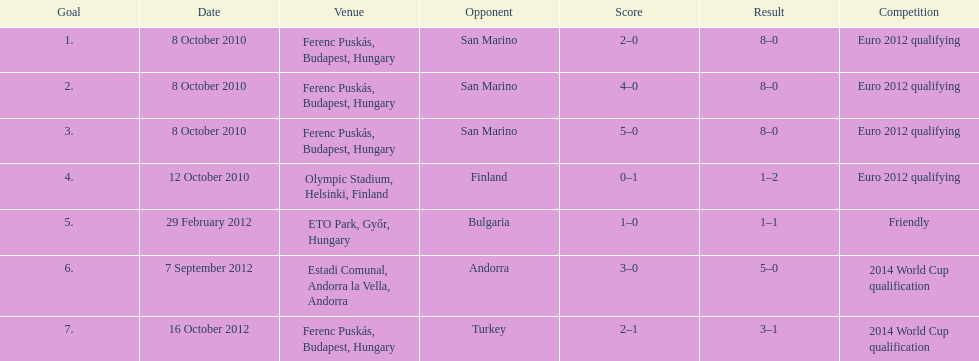Can you give me this table as a dict? {'header': ['Goal', 'Date', 'Venue', 'Opponent', 'Score', 'Result', 'Competition'], 'rows': [['1.', '8 October 2010', 'Ferenc Puskás, Budapest, Hungary', 'San Marino', '2–0', '8–0', 'Euro 2012 qualifying'], ['2.', '8 October 2010', 'Ferenc Puskás, Budapest, Hungary', 'San Marino', '4–0', '8–0', 'Euro 2012 qualifying'], ['3.', '8 October 2010', 'Ferenc Puskás, Budapest, Hungary', 'San Marino', '5–0', '8–0', 'Euro 2012 qualifying'], ['4.', '12 October 2010', 'Olympic Stadium, Helsinki, Finland', 'Finland', '0–1', '1–2', 'Euro 2012 qualifying'], ['5.', '29 February 2012', 'ETO Park, Győr, Hungary', 'Bulgaria', '1–0', '1–1', 'Friendly'], ['6.', '7 September 2012', 'Estadi Comunal, Andorra la Vella, Andorra', 'Andorra', '3–0', '5–0', '2014 World Cup qualification'], ['7.', '16 October 2012', 'Ferenc Puskás, Budapest, Hungary', 'Turkey', '2–1', '3–1', '2014 World Cup qualification']]} In which year did szalai score his initial international goal? 2010. 